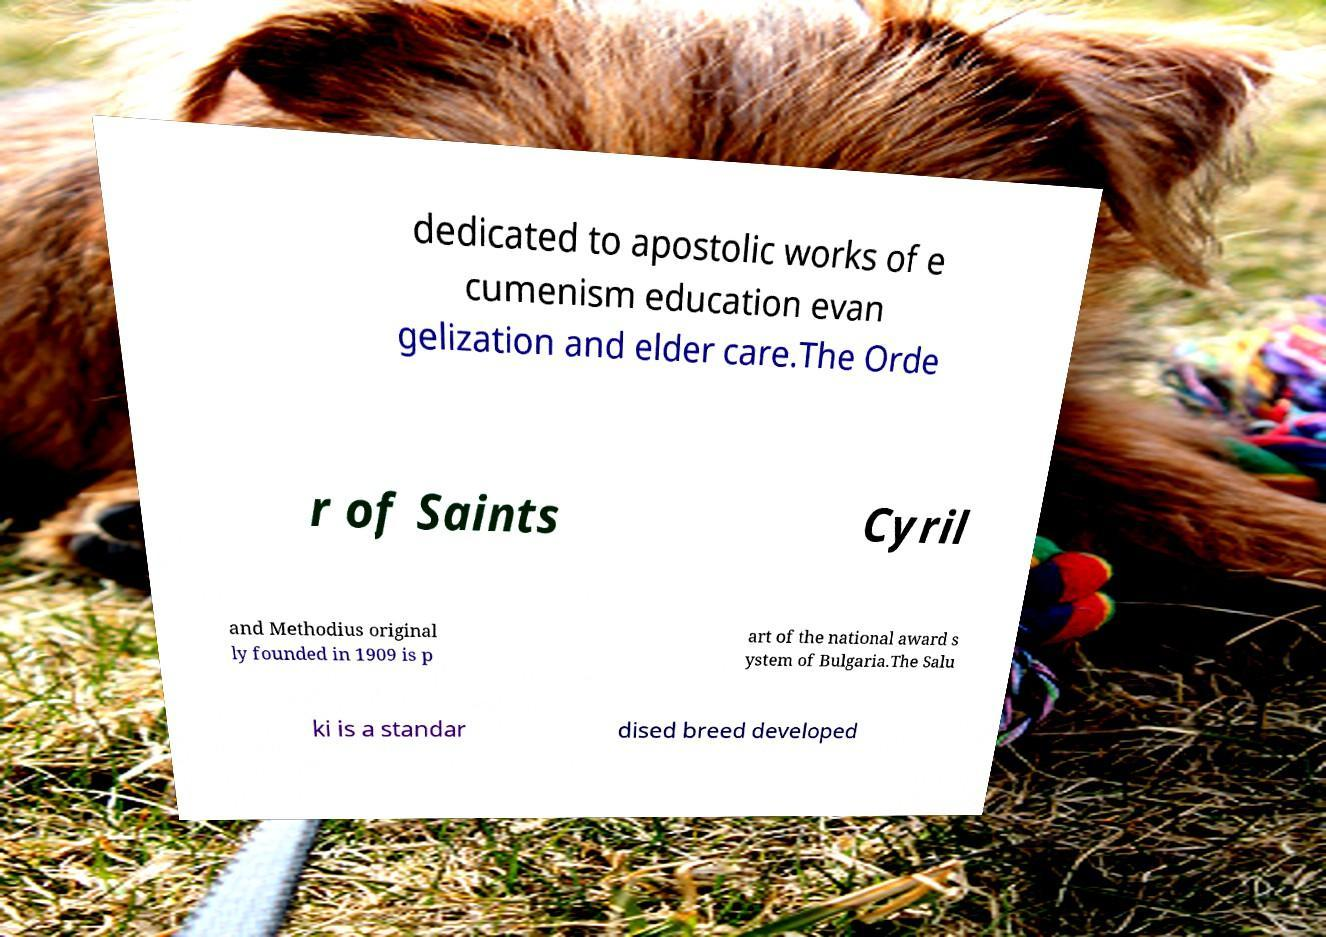Please read and relay the text visible in this image. What does it say? dedicated to apostolic works of e cumenism education evan gelization and elder care.The Orde r of Saints Cyril and Methodius original ly founded in 1909 is p art of the national award s ystem of Bulgaria.The Salu ki is a standar dised breed developed 